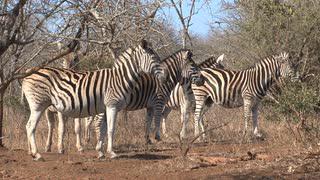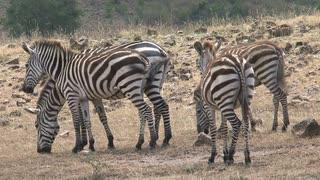The first image is the image on the left, the second image is the image on the right. Assess this claim about the two images: "The left image features a row of no more than seven zebras with bodies mostly parallel to one another and heads raised, and the right image includes zebras with lowered heads.". Correct or not? Answer yes or no. Yes. The first image is the image on the left, the second image is the image on the right. Given the left and right images, does the statement "The right image contains exactly two zebras." hold true? Answer yes or no. No. 